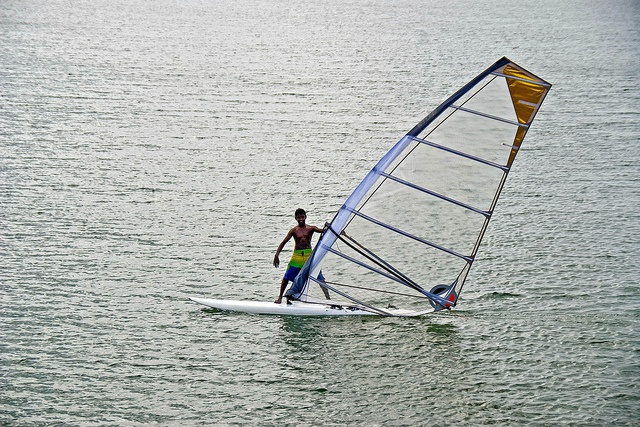Describe the objects in this image and their specific colors. I can see surfboard in darkgray and lightgray tones and people in darkgray, black, maroon, olive, and navy tones in this image. 